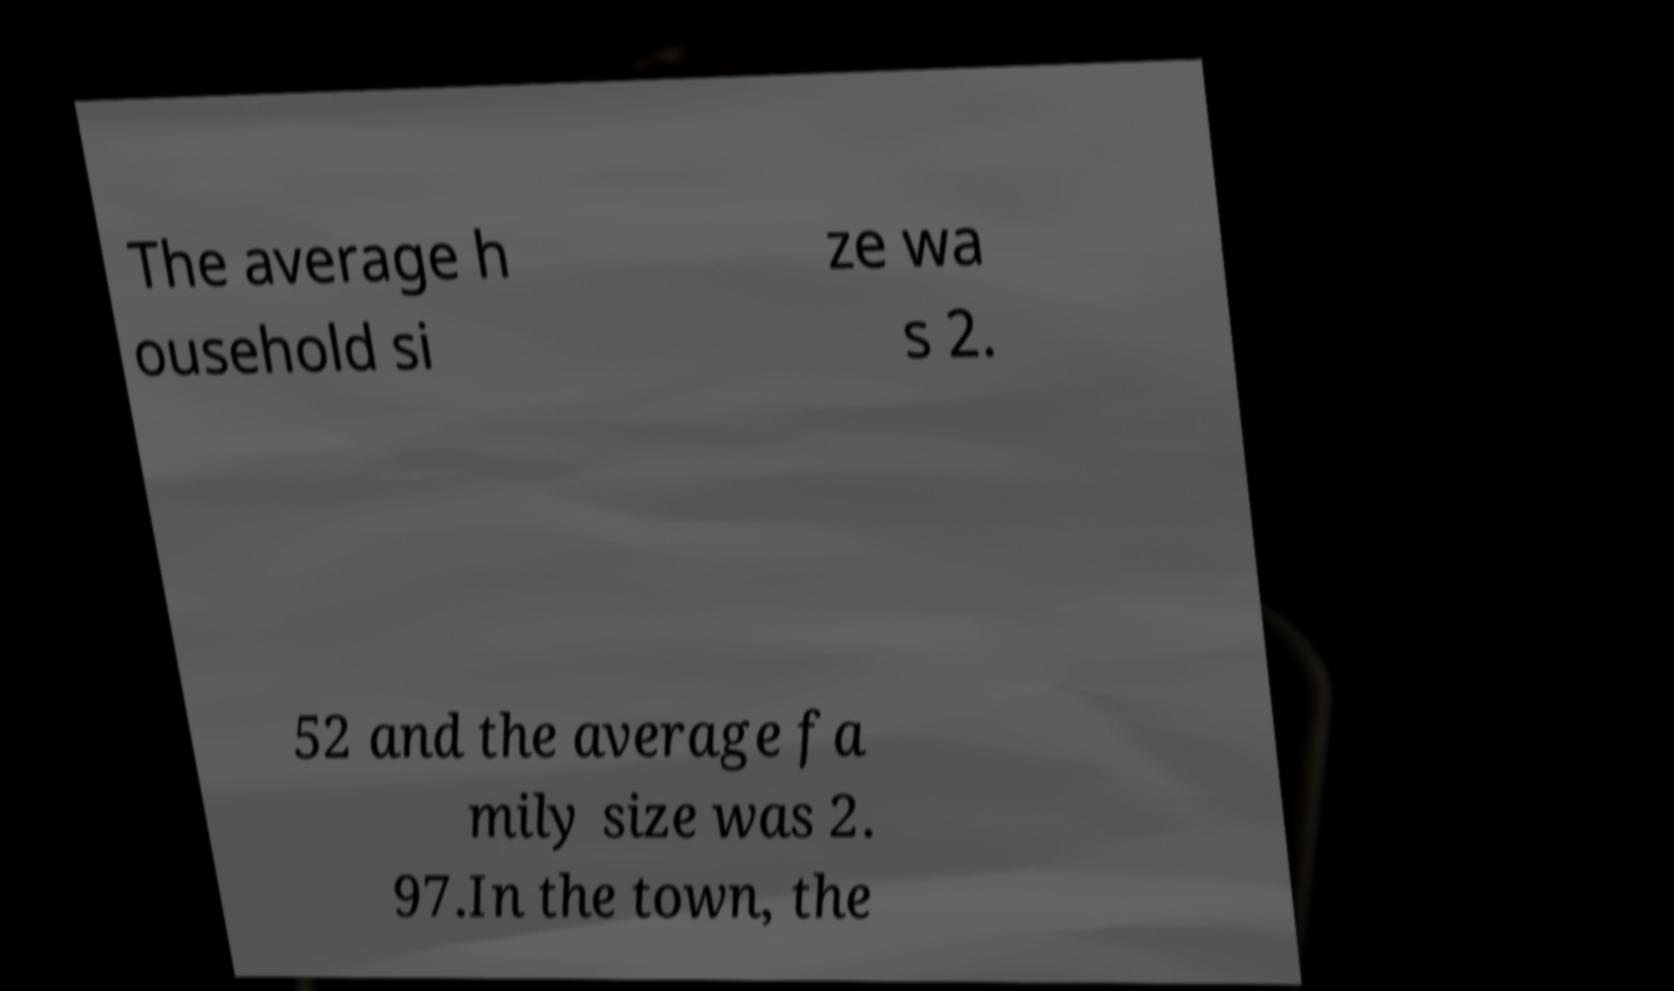Please read and relay the text visible in this image. What does it say? The average h ousehold si ze wa s 2. 52 and the average fa mily size was 2. 97.In the town, the 